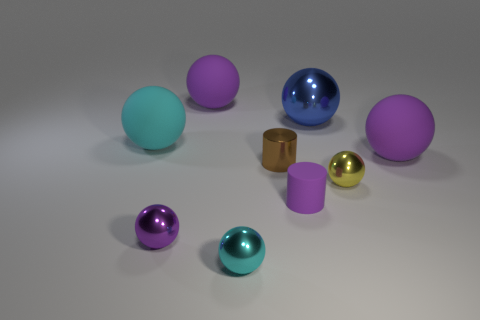Are any brown shiny cubes visible?
Provide a short and direct response. No. What size is the purple ball right of the purple rubber object that is in front of the matte thing that is right of the purple cylinder?
Your response must be concise. Large. What number of other things are the same size as the rubber cylinder?
Offer a terse response. 4. What is the size of the matte object behind the big blue thing?
Make the answer very short. Large. Is there any other thing that is the same color as the shiny cylinder?
Give a very brief answer. No. Do the cyan thing that is in front of the tiny rubber cylinder and the yellow sphere have the same material?
Your answer should be compact. Yes. How many tiny purple things are on the right side of the brown cylinder and on the left side of the matte cylinder?
Ensure brevity in your answer.  0. There is a matte object that is in front of the large purple rubber thing to the right of the tiny purple cylinder; what is its size?
Give a very brief answer. Small. Is the number of small yellow objects greater than the number of tiny metal spheres?
Offer a very short reply. No. There is a big sphere to the right of the yellow shiny thing; does it have the same color as the tiny sphere to the right of the brown metal thing?
Provide a short and direct response. No. 